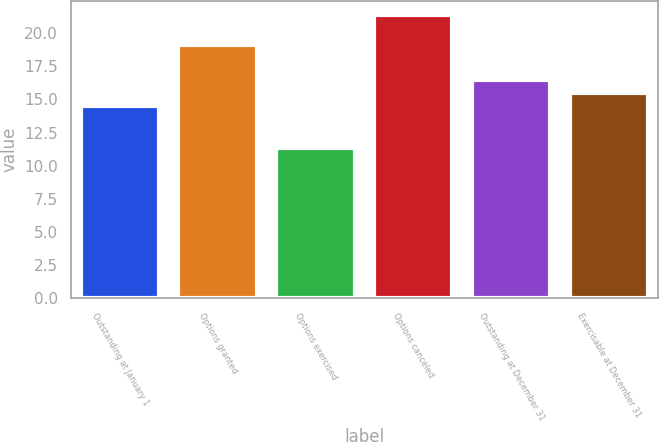Convert chart to OTSL. <chart><loc_0><loc_0><loc_500><loc_500><bar_chart><fcel>Outstanding at January 1<fcel>Options granted<fcel>Options exercised<fcel>Options canceled<fcel>Outstanding at December 31<fcel>Exercisable at December 31<nl><fcel>14.5<fcel>19.14<fcel>11.36<fcel>21.34<fcel>16.5<fcel>15.5<nl></chart> 